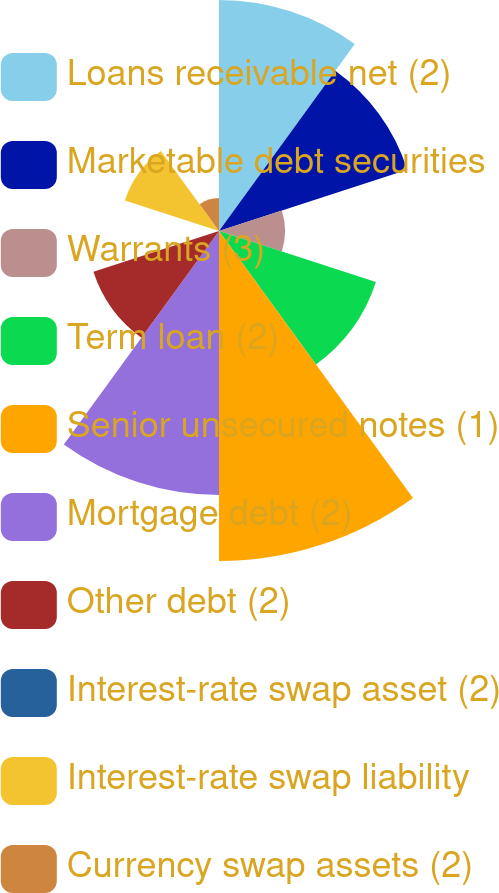Convert chart to OTSL. <chart><loc_0><loc_0><loc_500><loc_500><pie_chart><fcel>Loans receivable net (2)<fcel>Marketable debt securities<fcel>Warrants (3)<fcel>Term loan (2)<fcel>Senior unsecured notes (1)<fcel>Mortgage debt (2)<fcel>Other debt (2)<fcel>Interest-rate swap asset (2)<fcel>Interest-rate swap liability<fcel>Currency swap assets (2)<nl><fcel>15.22%<fcel>13.04%<fcel>4.35%<fcel>10.87%<fcel>21.74%<fcel>17.39%<fcel>8.7%<fcel>0.0%<fcel>6.52%<fcel>2.17%<nl></chart> 